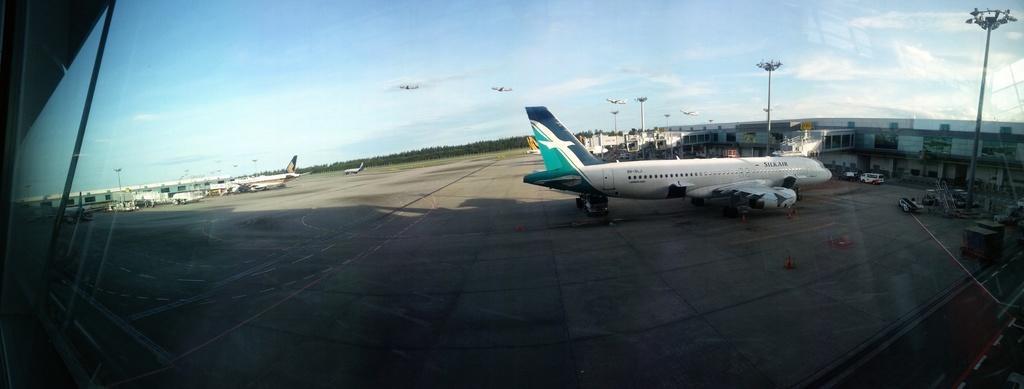Can you describe this image briefly? In this image we can see many planes. Also there are light poles and there are buildings. And there are few vehicles and cranes. And some flights are flying. In the background there is sky with clouds and there are trees. 